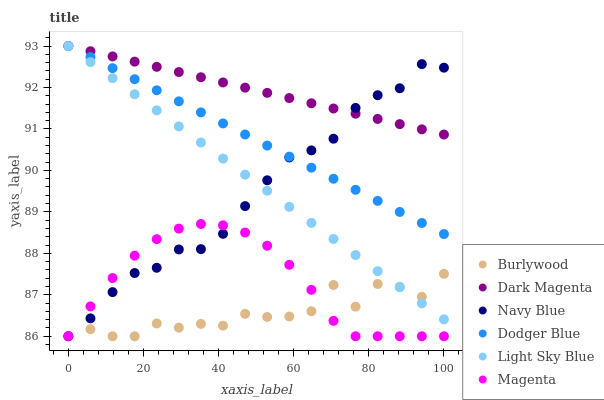Does Burlywood have the minimum area under the curve?
Answer yes or no. Yes. Does Dark Magenta have the maximum area under the curve?
Answer yes or no. Yes. Does Navy Blue have the minimum area under the curve?
Answer yes or no. No. Does Navy Blue have the maximum area under the curve?
Answer yes or no. No. Is Light Sky Blue the smoothest?
Answer yes or no. Yes. Is Burlywood the roughest?
Answer yes or no. Yes. Is Navy Blue the smoothest?
Answer yes or no. No. Is Navy Blue the roughest?
Answer yes or no. No. Does Burlywood have the lowest value?
Answer yes or no. Yes. Does Light Sky Blue have the lowest value?
Answer yes or no. No. Does Dodger Blue have the highest value?
Answer yes or no. Yes. Does Navy Blue have the highest value?
Answer yes or no. No. Is Magenta less than Light Sky Blue?
Answer yes or no. Yes. Is Dodger Blue greater than Magenta?
Answer yes or no. Yes. Does Dark Magenta intersect Navy Blue?
Answer yes or no. Yes. Is Dark Magenta less than Navy Blue?
Answer yes or no. No. Is Dark Magenta greater than Navy Blue?
Answer yes or no. No. Does Magenta intersect Light Sky Blue?
Answer yes or no. No. 